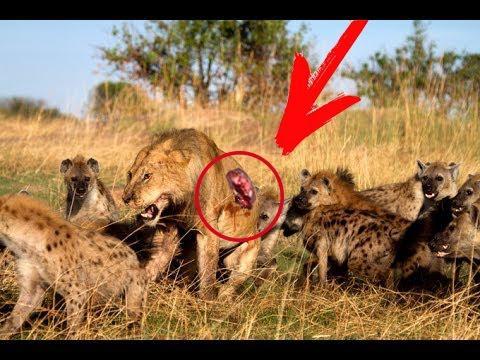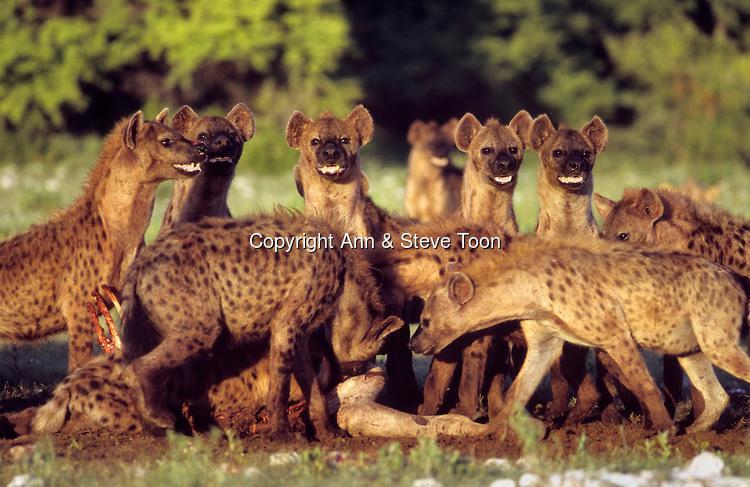The first image is the image on the left, the second image is the image on the right. For the images shown, is this caption "A lion is bleeding in one of the images." true? Answer yes or no. Yes. 